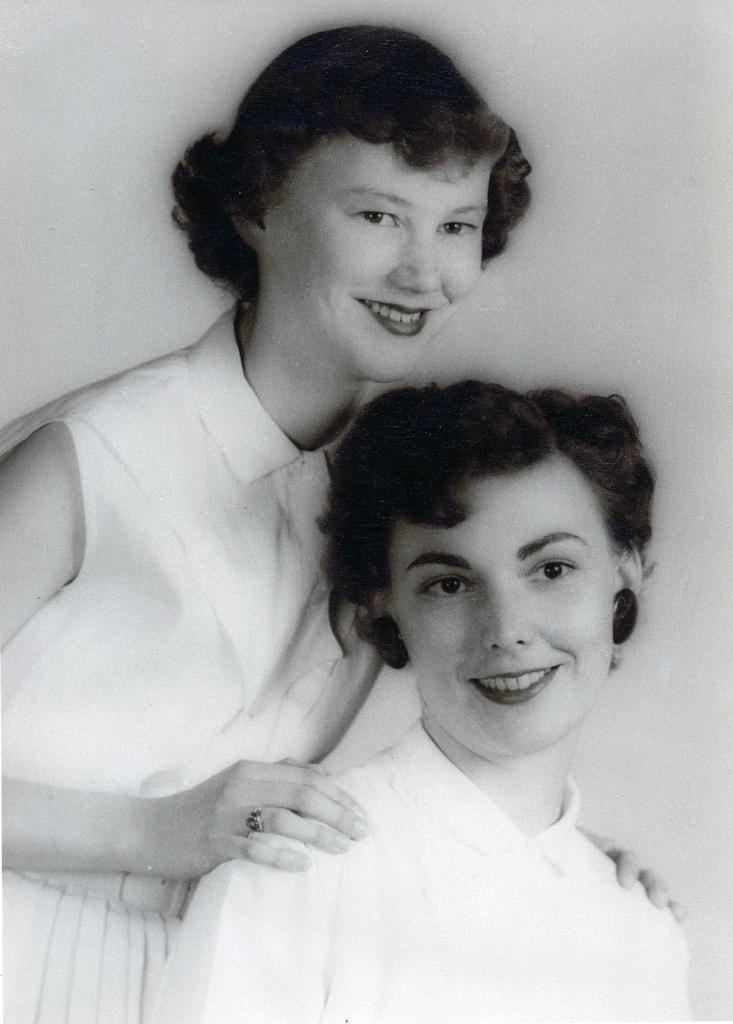Describe this image in one or two sentences. This is a black and white image where we can see two women are smiling. 